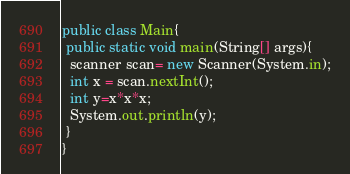<code> <loc_0><loc_0><loc_500><loc_500><_Java_>public class Main{
 public static void main(String[] args){
  scanner scan= new Scanner(System.in);
  int x = scan.nextInt();
  int y=x*x*x;
  System.out.println(y);
 }
}</code> 